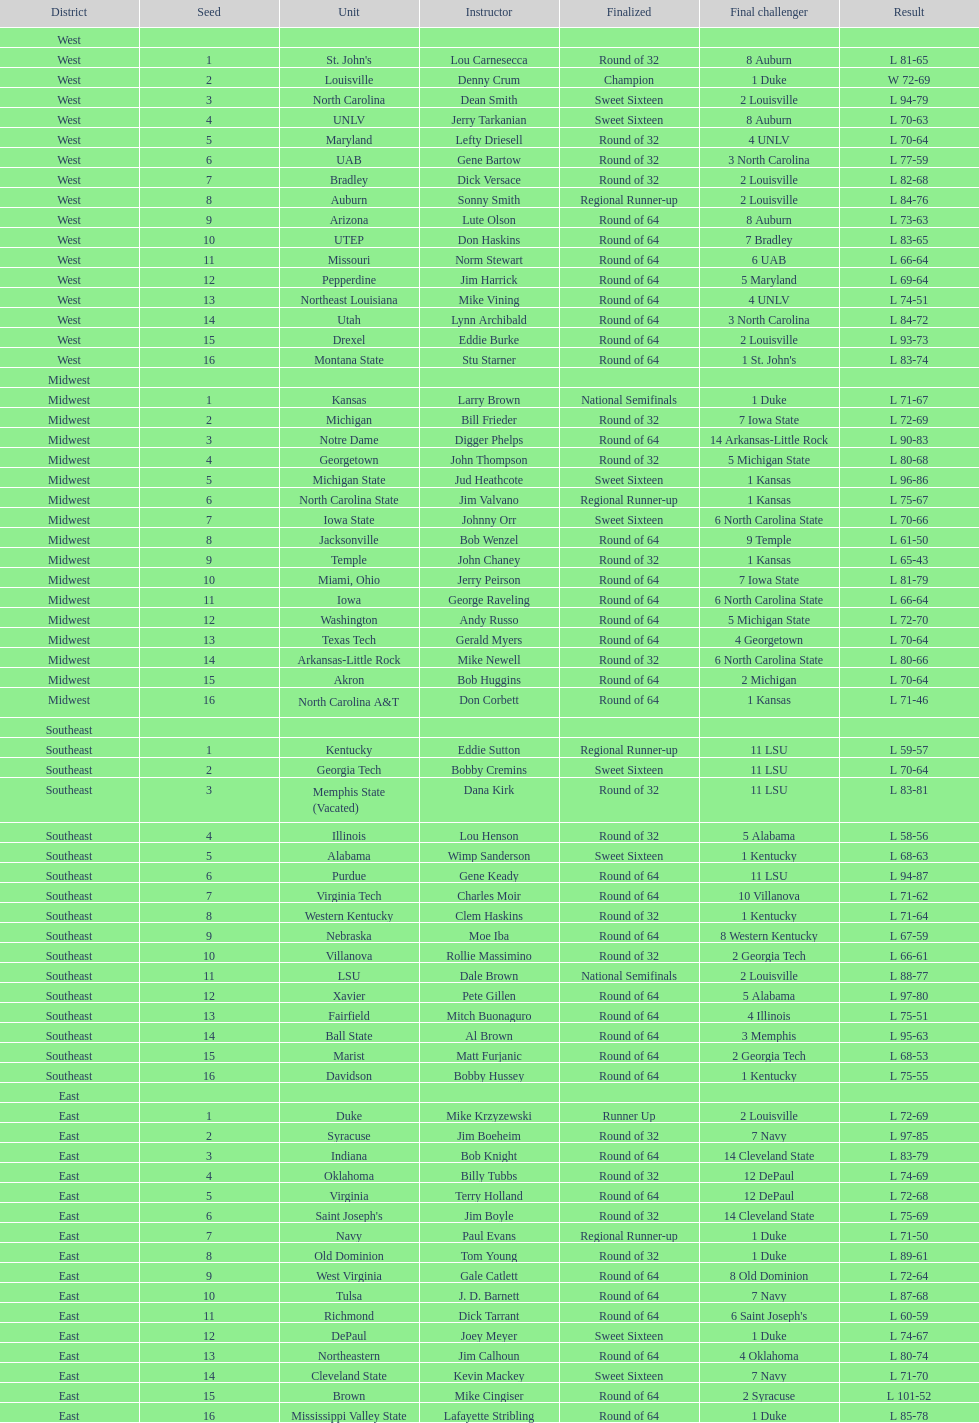North carolina and unlv each made it to which round? Sweet Sixteen. 